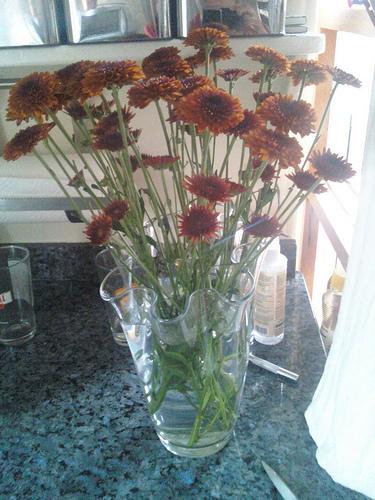Are these flowers still alive?
Give a very brief answer. Yes. What is in the vase of water?
Be succinct. Flowers. What color are the flowers in the vase?
Quick response, please. Orange. 